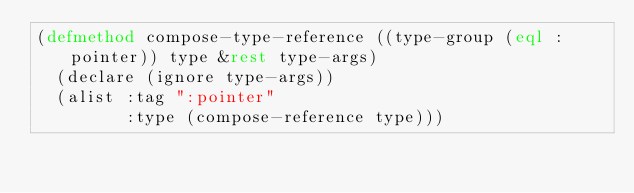Convert code to text. <code><loc_0><loc_0><loc_500><loc_500><_Lisp_>(defmethod compose-type-reference ((type-group (eql :pointer)) type &rest type-args)
  (declare (ignore type-args))
  (alist :tag ":pointer"
         :type (compose-reference type)))
</code> 